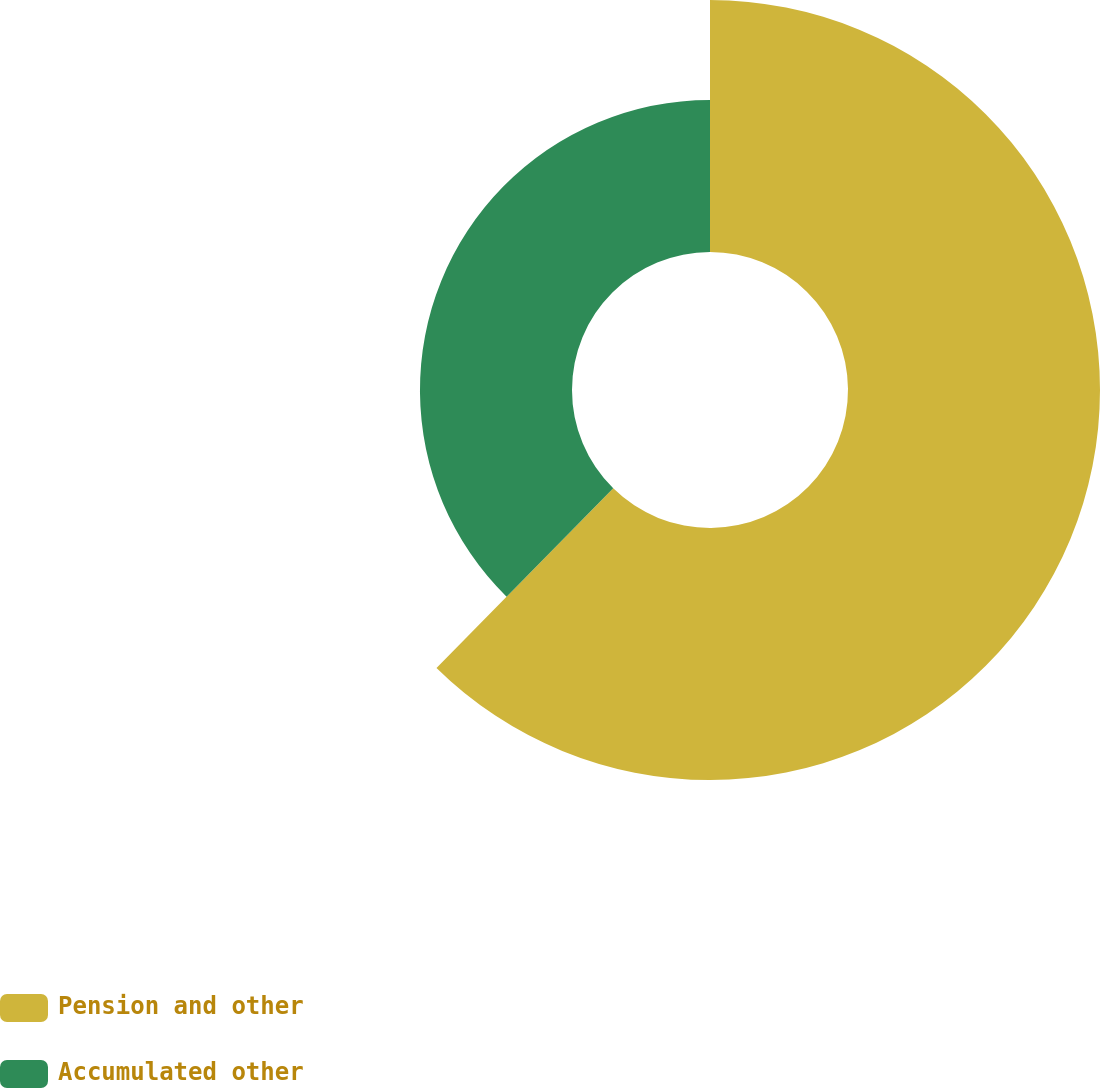Convert chart to OTSL. <chart><loc_0><loc_0><loc_500><loc_500><pie_chart><fcel>Pension and other<fcel>Accumulated other<nl><fcel>62.37%<fcel>37.63%<nl></chart> 